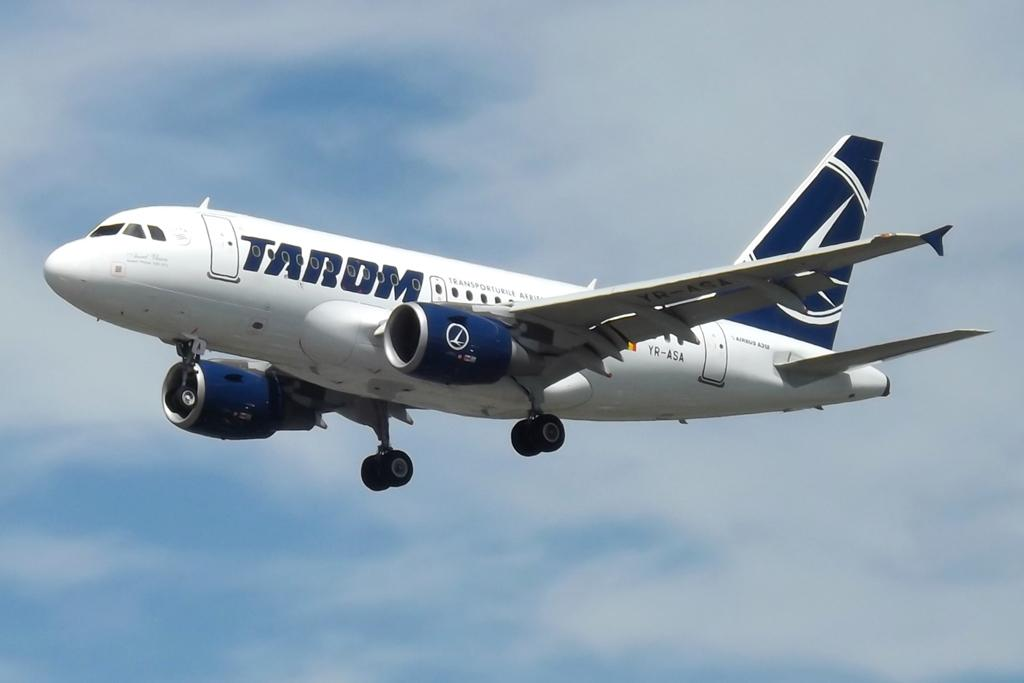<image>
Provide a brief description of the given image. a tardom airplane is flying through the sky 